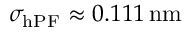Convert formula to latex. <formula><loc_0><loc_0><loc_500><loc_500>\sigma _ { h P F } \approx 0 . 1 1 1 \, n m</formula> 